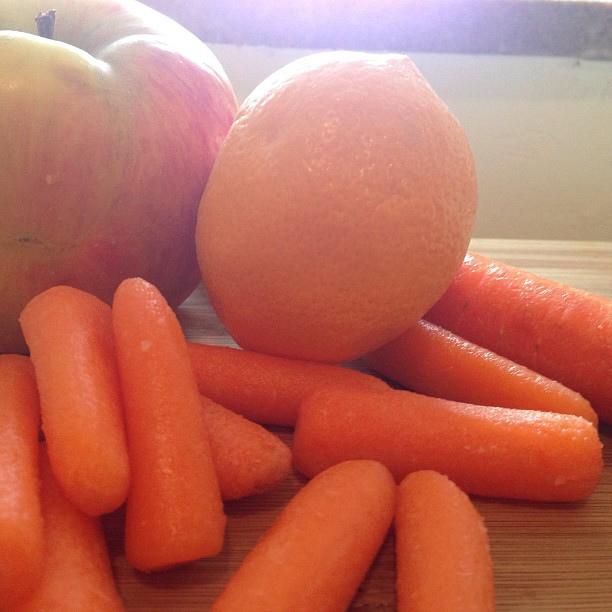What type of apple is in the background?
Write a very short answer. Red. What vegetables are in the image?
Give a very brief answer. Carrots. What kind of carrots are shown?
Write a very short answer. Baby. 